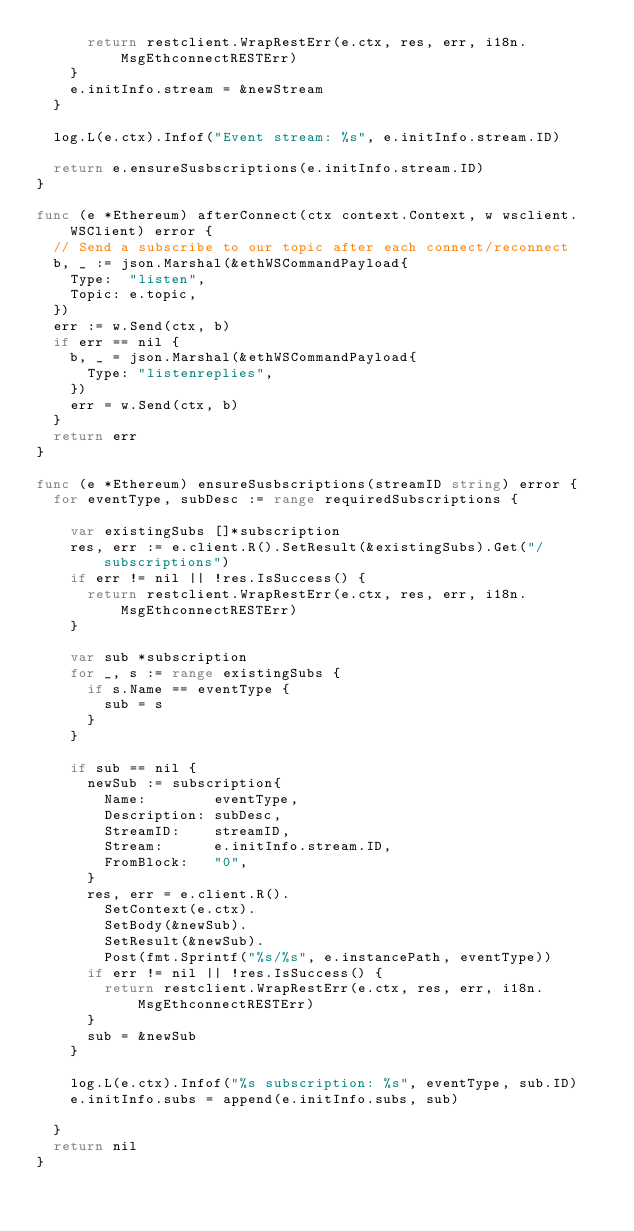Convert code to text. <code><loc_0><loc_0><loc_500><loc_500><_Go_>			return restclient.WrapRestErr(e.ctx, res, err, i18n.MsgEthconnectRESTErr)
		}
		e.initInfo.stream = &newStream
	}

	log.L(e.ctx).Infof("Event stream: %s", e.initInfo.stream.ID)

	return e.ensureSusbscriptions(e.initInfo.stream.ID)
}

func (e *Ethereum) afterConnect(ctx context.Context, w wsclient.WSClient) error {
	// Send a subscribe to our topic after each connect/reconnect
	b, _ := json.Marshal(&ethWSCommandPayload{
		Type:  "listen",
		Topic: e.topic,
	})
	err := w.Send(ctx, b)
	if err == nil {
		b, _ = json.Marshal(&ethWSCommandPayload{
			Type: "listenreplies",
		})
		err = w.Send(ctx, b)
	}
	return err
}

func (e *Ethereum) ensureSusbscriptions(streamID string) error {
	for eventType, subDesc := range requiredSubscriptions {

		var existingSubs []*subscription
		res, err := e.client.R().SetResult(&existingSubs).Get("/subscriptions")
		if err != nil || !res.IsSuccess() {
			return restclient.WrapRestErr(e.ctx, res, err, i18n.MsgEthconnectRESTErr)
		}

		var sub *subscription
		for _, s := range existingSubs {
			if s.Name == eventType {
				sub = s
			}
		}

		if sub == nil {
			newSub := subscription{
				Name:        eventType,
				Description: subDesc,
				StreamID:    streamID,
				Stream:      e.initInfo.stream.ID,
				FromBlock:   "0",
			}
			res, err = e.client.R().
				SetContext(e.ctx).
				SetBody(&newSub).
				SetResult(&newSub).
				Post(fmt.Sprintf("%s/%s", e.instancePath, eventType))
			if err != nil || !res.IsSuccess() {
				return restclient.WrapRestErr(e.ctx, res, err, i18n.MsgEthconnectRESTErr)
			}
			sub = &newSub
		}

		log.L(e.ctx).Infof("%s subscription: %s", eventType, sub.ID)
		e.initInfo.subs = append(e.initInfo.subs, sub)

	}
	return nil
}
</code> 